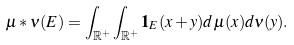<formula> <loc_0><loc_0><loc_500><loc_500>\mu * \nu ( E ) = \int _ { \mathbb { R } ^ { + } } \int _ { \mathbb { R } ^ { + } } \mathbf 1 _ { E } ( x + y ) d \mu ( x ) d \nu ( y ) .</formula> 